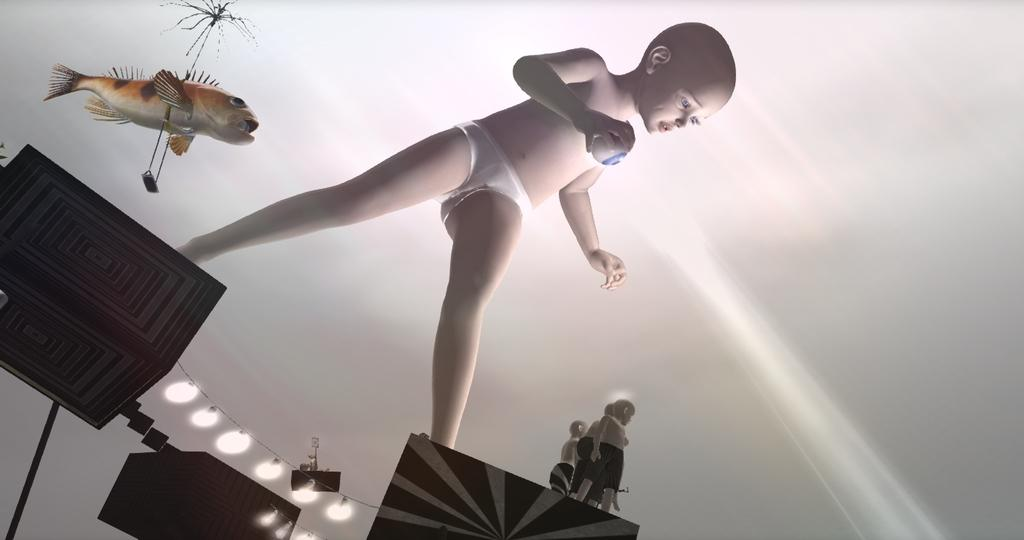Who is present in the image? There is a boy in the image. What is the boy doing in the image? The boy is standing on boxes. What type of lighting can be seen in the image? There are fish lights in the image. What else can be seen in the image besides the boy and the fish lights? There are toys in the image. What type of oil is being used to lubricate the toys in the image? There is no oil present in the image, and the toys do not require lubrication. 